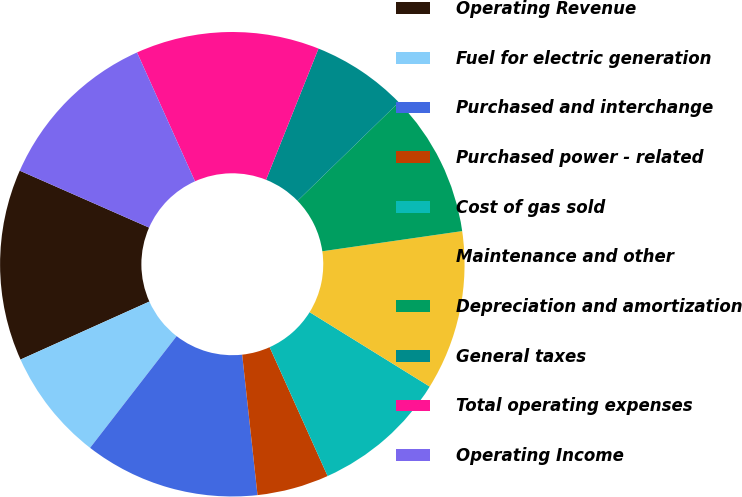Convert chart. <chart><loc_0><loc_0><loc_500><loc_500><pie_chart><fcel>Operating Revenue<fcel>Fuel for electric generation<fcel>Purchased and interchange<fcel>Purchased power - related<fcel>Cost of gas sold<fcel>Maintenance and other<fcel>Depreciation and amortization<fcel>General taxes<fcel>Total operating expenses<fcel>Operating Income<nl><fcel>13.33%<fcel>7.78%<fcel>12.22%<fcel>5.0%<fcel>9.44%<fcel>11.11%<fcel>10.0%<fcel>6.67%<fcel>12.78%<fcel>11.67%<nl></chart> 